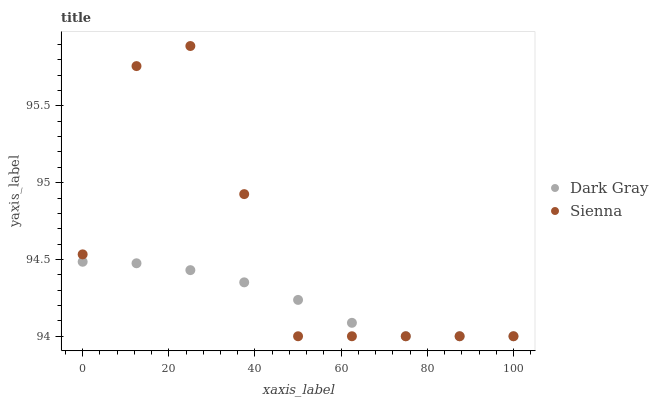Does Dark Gray have the minimum area under the curve?
Answer yes or no. Yes. Does Sienna have the maximum area under the curve?
Answer yes or no. Yes. Does Sienna have the minimum area under the curve?
Answer yes or no. No. Is Dark Gray the smoothest?
Answer yes or no. Yes. Is Sienna the roughest?
Answer yes or no. Yes. Is Sienna the smoothest?
Answer yes or no. No. Does Dark Gray have the lowest value?
Answer yes or no. Yes. Does Sienna have the highest value?
Answer yes or no. Yes. Does Dark Gray intersect Sienna?
Answer yes or no. Yes. Is Dark Gray less than Sienna?
Answer yes or no. No. Is Dark Gray greater than Sienna?
Answer yes or no. No. 